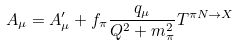Convert formula to latex. <formula><loc_0><loc_0><loc_500><loc_500>A _ { \mu } = A ^ { \prime } _ { \mu } + f _ { \pi } \frac { q _ { \mu } } { Q ^ { 2 } + m _ { \pi } ^ { 2 } } T ^ { \pi N \rightarrow X }</formula> 